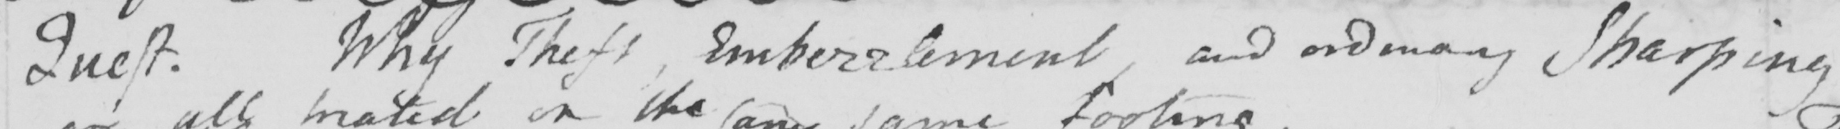What is written in this line of handwriting? Theft . Why Theft , Embezzlement , and ordinary Sharping 